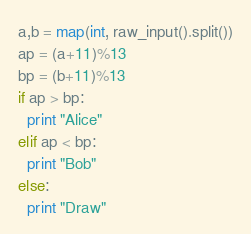<code> <loc_0><loc_0><loc_500><loc_500><_Python_>a,b = map(int, raw_input().split())
ap = (a+11)%13
bp = (b+11)%13
if ap > bp:
  print "Alice"
elif ap < bp:
  print "Bob"
else:
  print "Draw"</code> 